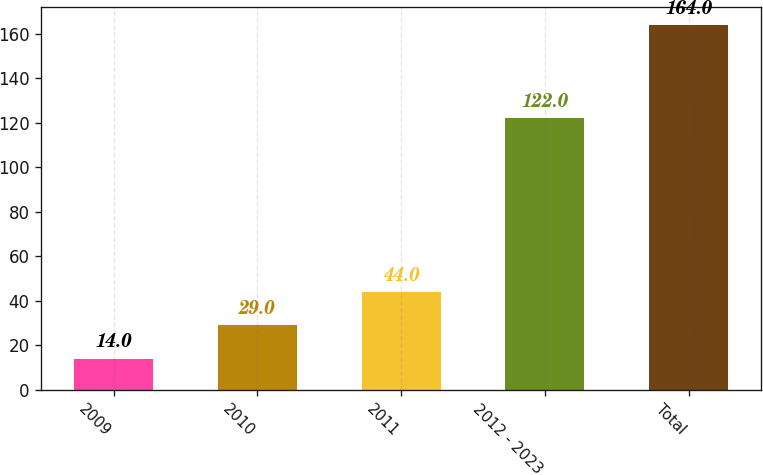<chart> <loc_0><loc_0><loc_500><loc_500><bar_chart><fcel>2009<fcel>2010<fcel>2011<fcel>2012 - 2023<fcel>Total<nl><fcel>14<fcel>29<fcel>44<fcel>122<fcel>164<nl></chart> 